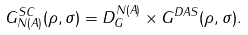<formula> <loc_0><loc_0><loc_500><loc_500>G _ { N ( A ) } ^ { S C } ( \rho , \sigma ) = D _ { G } ^ { N ( A ) } \times G ^ { D A S } ( \rho , \sigma ) .</formula> 